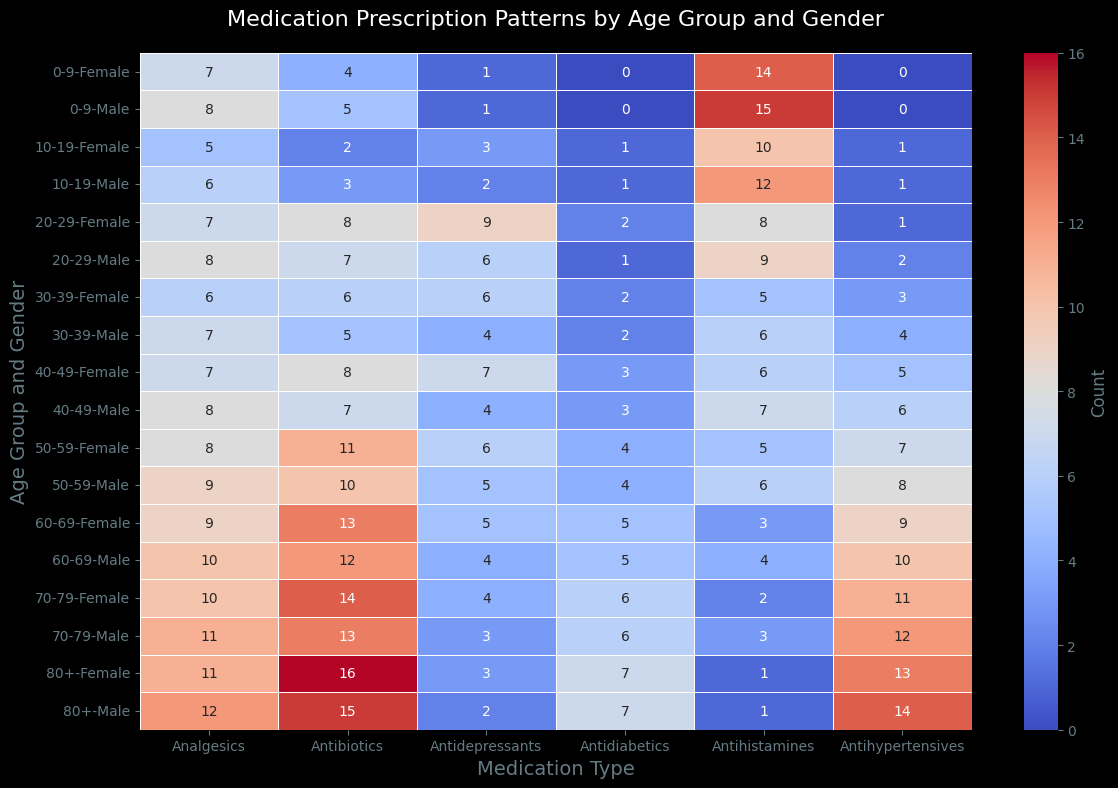What's the age group and gender with the highest count of antibiotics? To determine the age group and gender with the highest count of antibiotics, locate the antibiotics column in the heatmap and identify the cell with the highest value. The value is 16, which corresponds to the "80+" age group and female gender.
Answer: 80+ Female Which medication type has the highest total count for females in the 20-29 age group? Sum the counts of all medication types for females in the 20-29 age group. These are 8 (Antibiotics), 9 (Antidepressants), 7 (Analgesics), 1 (Antihypertensives), 2 (Antidiabetics), and 8 (Antihistamines). The highest value among these is 9 for Antidepressants.
Answer: Antidepressants What is the most frequently prescribed medication type for males in the 70-79 age group? Check the counts of various medication types for males in the 70-79 age group in the heatmap. The highest count is 13 for Antibiotics.
Answer: Antibiotics Compare the counts of Antihypertensives for males and females in the 50-59 age group. Which gender has a higher count? Locate the Antihypertensives column for the 50-59 age group. The counts are 8 for males and 7 for females. Males have a higher count than females.
Answer: Males How does the prescription pattern for Antidiabetics change from the 60-69 age group to the 80+ age group in males? Check the counts of Antidiabetics for males in the 60-69 age group (5) and in the 80+ age group (7). There is an increase in the count of Antidiabetics from 5 to 7.
Answer: Increase Which age group and gender have the lowest count for Antidepressants? Look at the Antidepressants column and identify the lowest value across all age groups and genders. The lowest value is 1, found in the 0-9 age group for both males and females.
Answer: 0-9 Male and Female What is the sum of Analgesics prescribed for the age group 30-39 across both genders? Add the values for Analgesics in the 30-39 age group for both males (7) and females (6). The sum is 7 + 6 = 13.
Answer: 13 Which medication type shows an equal count for males and females in the 40-49 age group? Locate the 40-49 age group and compare the counts for each medication type between males and females. Antihypertensives and Antidiabetics both show equal counts (6 and 3 respectively).
Answer: Antihypertensives and Antidiabetics Describe the visual pattern of Analgesics prescription across age groups. Observe the color intensity in the Analgesics column across age groups. The heatmap shows an increasing intensity of red color as the age group increases, indicating a higher count of Analgesics prescriptions in older age groups.
Answer: Increasing with age How does the count of Antihistamines for females change as age increases? Track the counts of Antihistamines for females across all age groups. The counts decrease consistently from 0-9 (14) to 80+ (1).
Answer: Decrease 